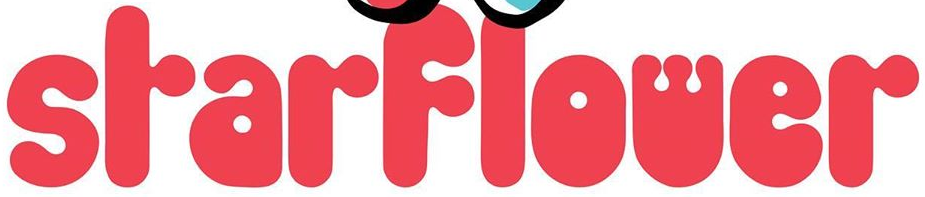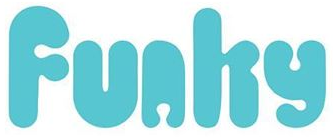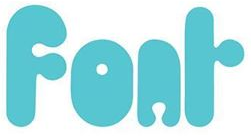Identify the words shown in these images in order, separated by a semicolon. SrarFlower; Funhy; Fonr 